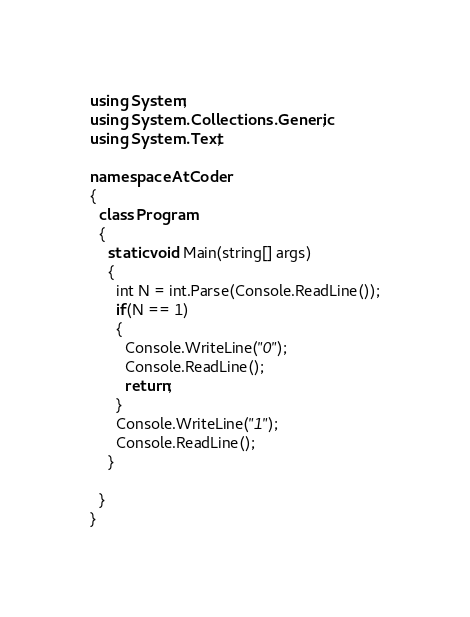<code> <loc_0><loc_0><loc_500><loc_500><_C#_>using System;
using System.Collections.Generic;
using System.Text;

namespace AtCoder
{
  class Program
  {
    static void Main(string[] args)
    {
      int N = int.Parse(Console.ReadLine());
      if(N == 1)
      {
        Console.WriteLine("0");
        Console.ReadLine();
        return;
      }
      Console.WriteLine("1");
      Console.ReadLine();
    }

  }
}</code> 